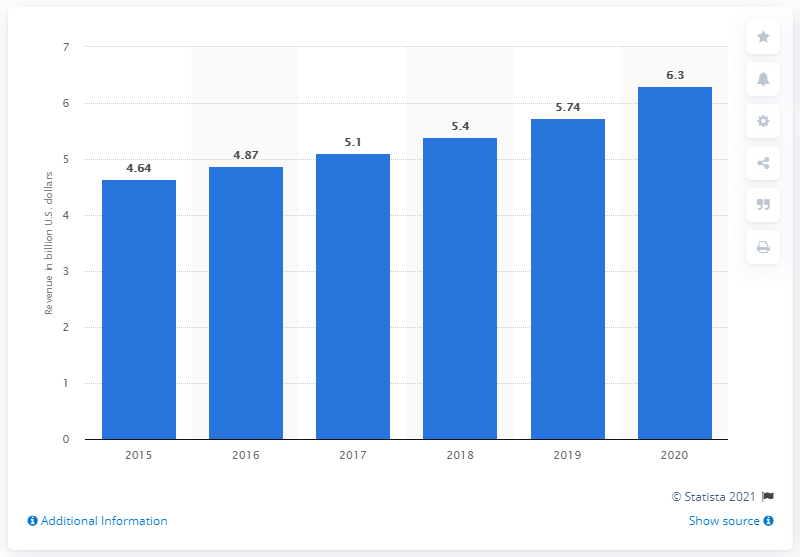Specify some key components in this picture. The revenue of RSM International increased by 6.3% in 2020. In 2020, the total revenue of RSM International was 6.3 million. 